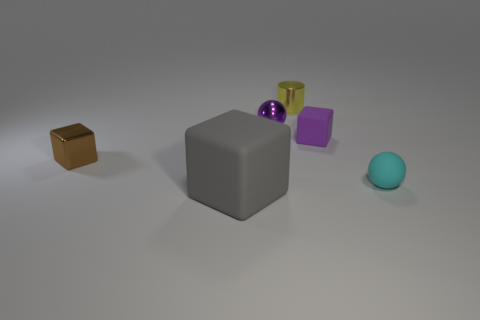Is there any other thing that has the same size as the gray thing?
Ensure brevity in your answer.  No. Do the cylinder and the purple sphere have the same size?
Ensure brevity in your answer.  Yes. What material is the purple thing that is behind the small purple rubber object?
Offer a very short reply. Metal. What material is the brown thing that is the same shape as the gray object?
Ensure brevity in your answer.  Metal. Is there a big gray block to the left of the shiny thing to the left of the gray object?
Provide a succinct answer. No. Is the shape of the brown metallic thing the same as the gray thing?
Offer a very short reply. Yes. What is the shape of the small purple thing that is the same material as the cyan ball?
Give a very brief answer. Cube. There is a sphere that is in front of the shiny block; is its size the same as the object behind the small purple metallic thing?
Your response must be concise. Yes. Are there more tiny yellow metal cylinders in front of the brown metallic thing than gray objects that are to the right of the small cyan rubber ball?
Your answer should be compact. No. How many other objects are there of the same color as the matte ball?
Your answer should be very brief. 0. 